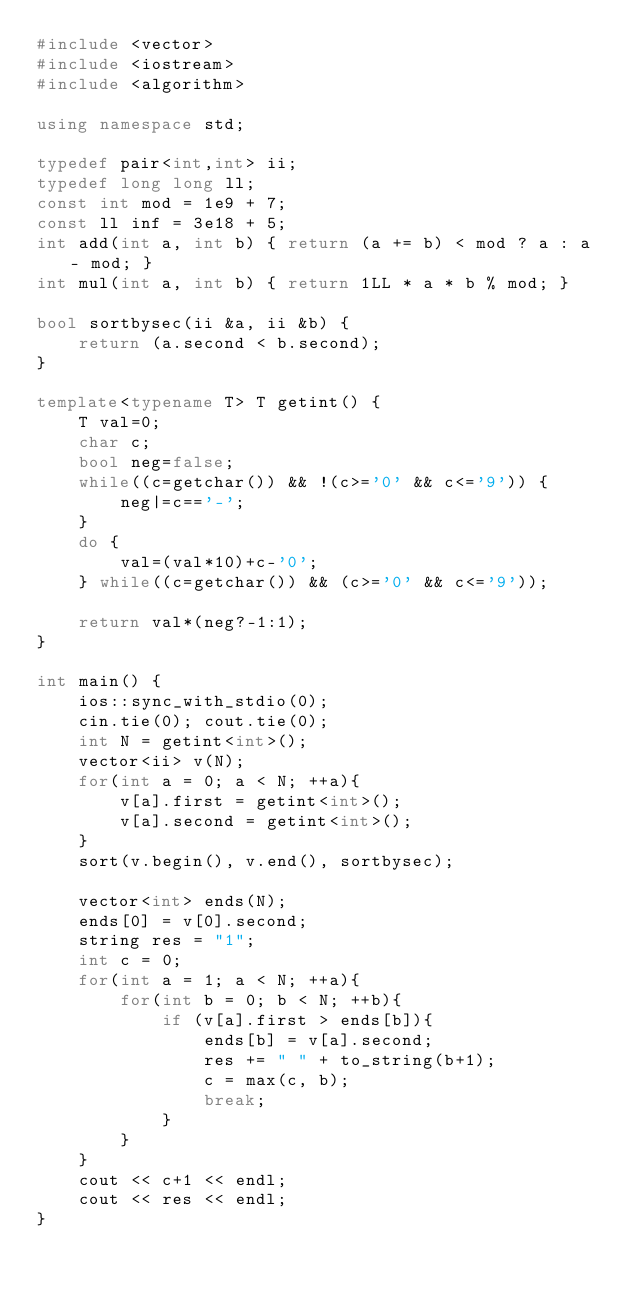Convert code to text. <code><loc_0><loc_0><loc_500><loc_500><_C++_>#include <vector>
#include <iostream>
#include <algorithm>

using namespace std;

typedef pair<int,int> ii;
typedef long long ll;
const int mod = 1e9 + 7;
const ll inf = 3e18 + 5;
int add(int a, int b) { return (a += b) < mod ? a : a - mod; }
int mul(int a, int b) { return 1LL * a * b % mod; }

bool sortbysec(ii &a, ii &b) { 
    return (a.second < b.second); 
} 

template<typename T> T getint() {
	T val=0;
	char c;
	bool neg=false;
	while((c=getchar()) && !(c>='0' && c<='9')) {
		neg|=c=='-';
	}
	do {
		val=(val*10)+c-'0';
	} while((c=getchar()) && (c>='0' && c<='9'));
 
	return val*(neg?-1:1);
}

int main() { 
    ios::sync_with_stdio(0);
    cin.tie(0); cout.tie(0);
    int N = getint<int>(); 
    vector<ii> v(N);
    for(int a = 0; a < N; ++a){
        v[a].first = getint<int>();
        v[a].second = getint<int>();
    }
    sort(v.begin(), v.end(), sortbysec); 
    
    vector<int> ends(N);
    ends[0] = v[0].second;
    string res = "1";
    int c = 0;
    for(int a = 1; a < N; ++a){
        for(int b = 0; b < N; ++b){
            if (v[a].first > ends[b]){
                ends[b] = v[a].second;
                res += " " + to_string(b+1);
                c = max(c, b);
                break;
            }
        }
    }
    cout << c+1 << endl;
    cout << res << endl;
}</code> 